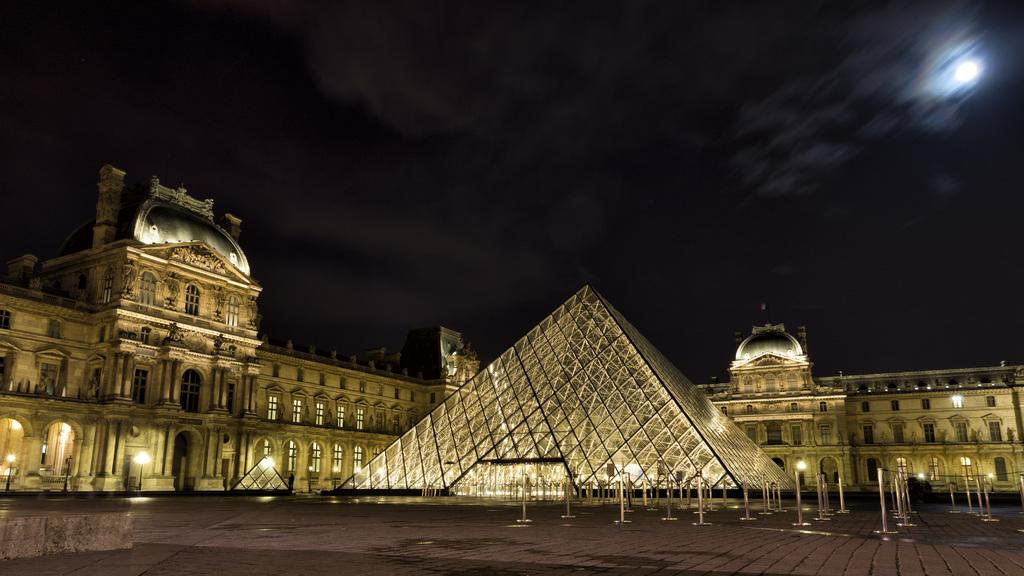What is the main structure in the image? There is a glass pyramid in the image. What can be seen in the background of the image? There is a building in the background of the image. What is visible at the top of the image? The sky is visible at the top of the image. What might be used for illumination in the image? There are lights present in the image. How many pies are displayed on the glass pyramid in the image? There are no pies present in the image; the main subject is a glass pyramid. Is there a glove visible on the glass pyramid in the image? There is no glove visible on the glass pyramid in the image. 